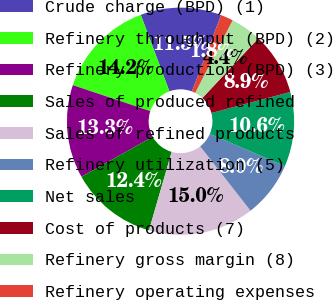Convert chart to OTSL. <chart><loc_0><loc_0><loc_500><loc_500><pie_chart><fcel>Crude charge (BPD) (1)<fcel>Refinery throughput (BPD) (2)<fcel>Refinery production (BPD) (3)<fcel>Sales of produced refined<fcel>Sales of refined products<fcel>Refinery utilization (5)<fcel>Net sales<fcel>Cost of products (7)<fcel>Refinery gross margin (8)<fcel>Refinery operating expenses<nl><fcel>11.5%<fcel>14.16%<fcel>13.27%<fcel>12.39%<fcel>15.04%<fcel>7.96%<fcel>10.62%<fcel>8.85%<fcel>4.42%<fcel>1.77%<nl></chart> 